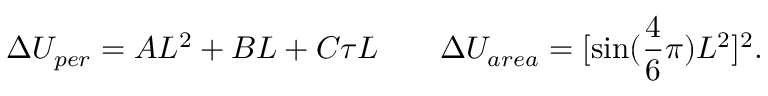Convert formula to latex. <formula><loc_0><loc_0><loc_500><loc_500>\Delta U _ { p e r } = A L ^ { 2 } + B L + C \tau L \, \Delta U _ { a r e a } = [ \sin ( \frac { 4 } { 6 } \pi ) L ^ { 2 } ] ^ { 2 } .</formula> 